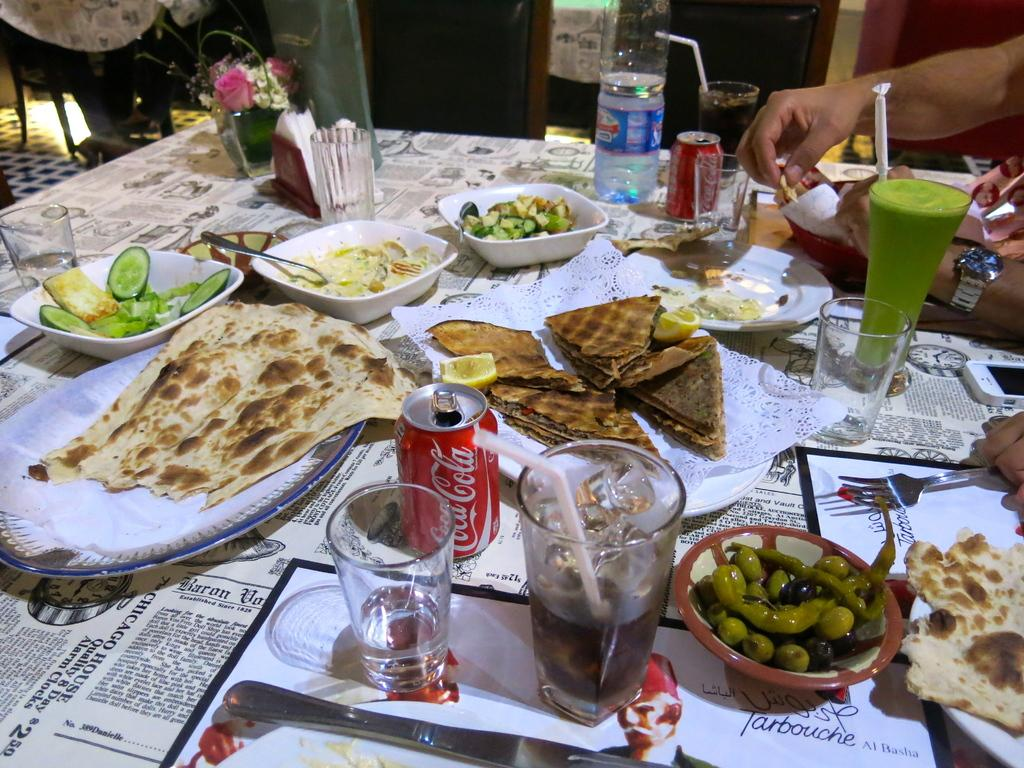What objects are located at the bottom of the image? There are glasses at the bottom of the image. What type of beverage container is present in the image? There is a coke tin in the image. What can be seen on the plates in the image? There are food items on plates in the image. What is the setting of the image? The image depicts a dining table. What action is being performed by human hands in the image? Human hands are taking food on the right side of the image. What type of game is being played on the table in the image? There is no game being played on the table in the image; it depicts a dining table with food and beverages. Can you describe the detail on the coke tin? There is no specific detail mentioned in the facts, so we cannot describe it. 